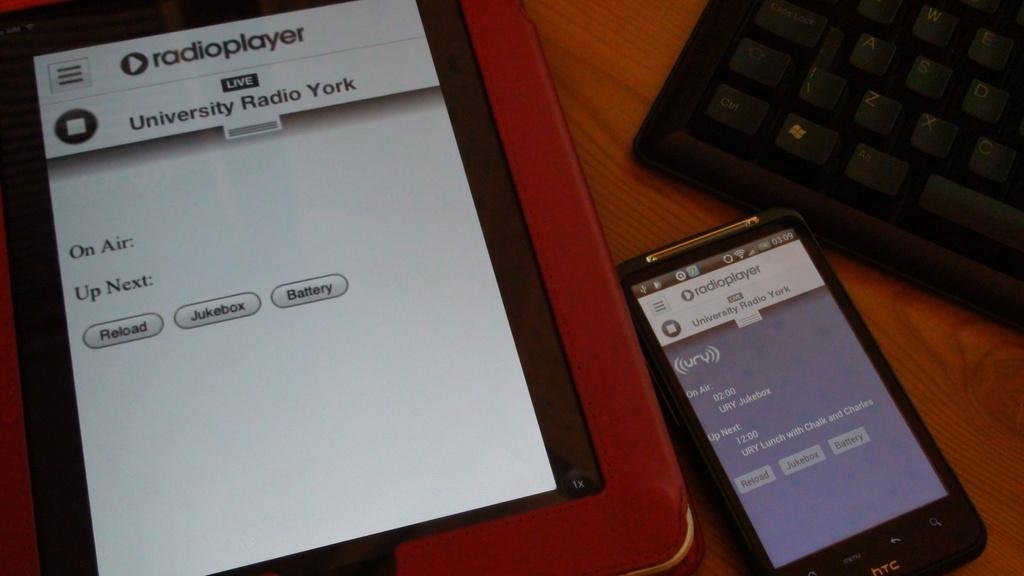<image>
Relay a brief, clear account of the picture shown. a phone with the word radioplayer at the top 